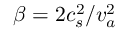<formula> <loc_0><loc_0><loc_500><loc_500>\beta = 2 c _ { s } ^ { 2 } / v _ { a } ^ { 2 }</formula> 